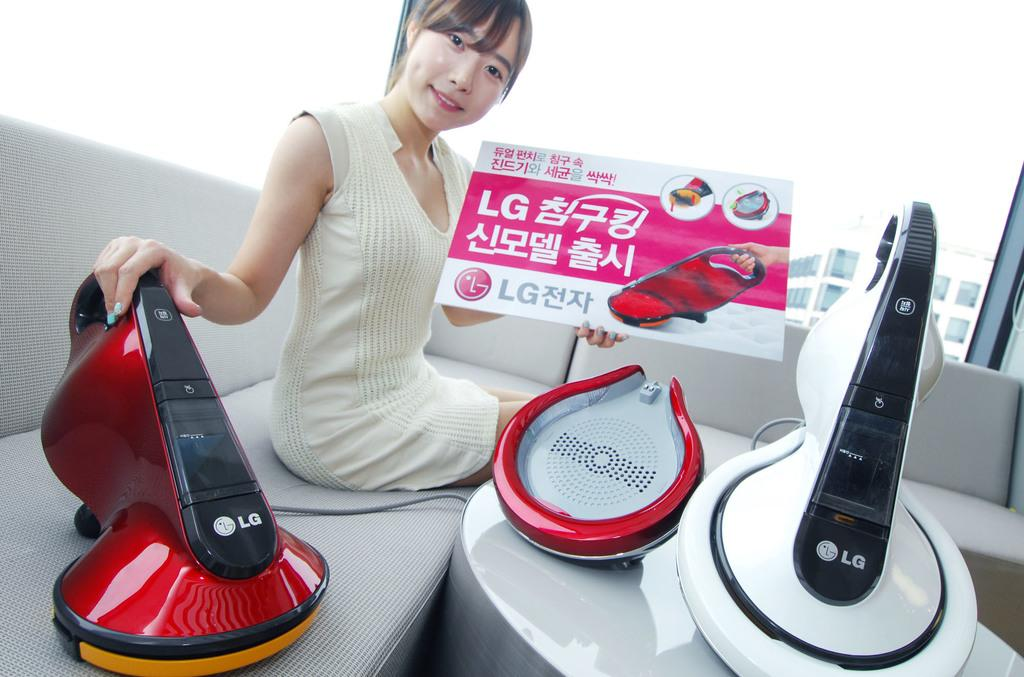Who is the main subject in the image? There is a woman in the image. What is the woman doing in the image? The woman is seated on a sofa and holding a placard. What is in front of the woman? There are machines in front of the woman. What can be seen in the background of the image? There is a building in the background of the image. What type of comb is the woman using on her stomach in the image? There is no comb or any reference to a stomach in the image; the woman is holding a placard and sitting in front of machines. 